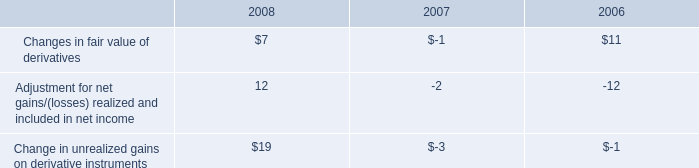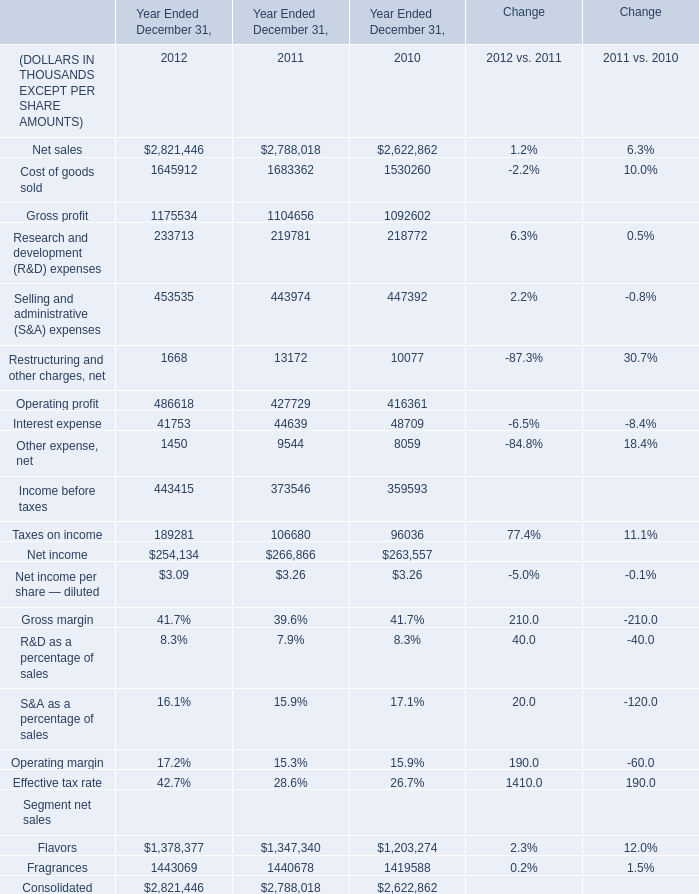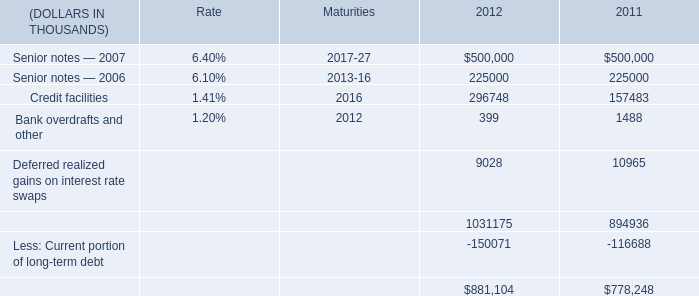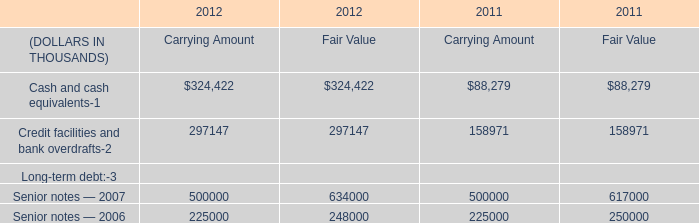What was the total amount of Operating profit, Interest expense, Other expense, net and Income before taxes in 2011 for Year Ended December 31, ? (in Thousand) 
Computations: (((427729 + 44639) + 9544) + 373546)
Answer: 855458.0. 